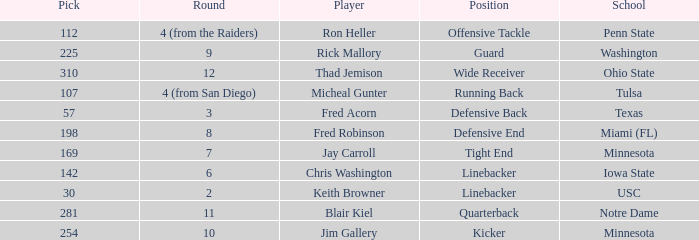What is the highest pick from Washington? 225.0. 